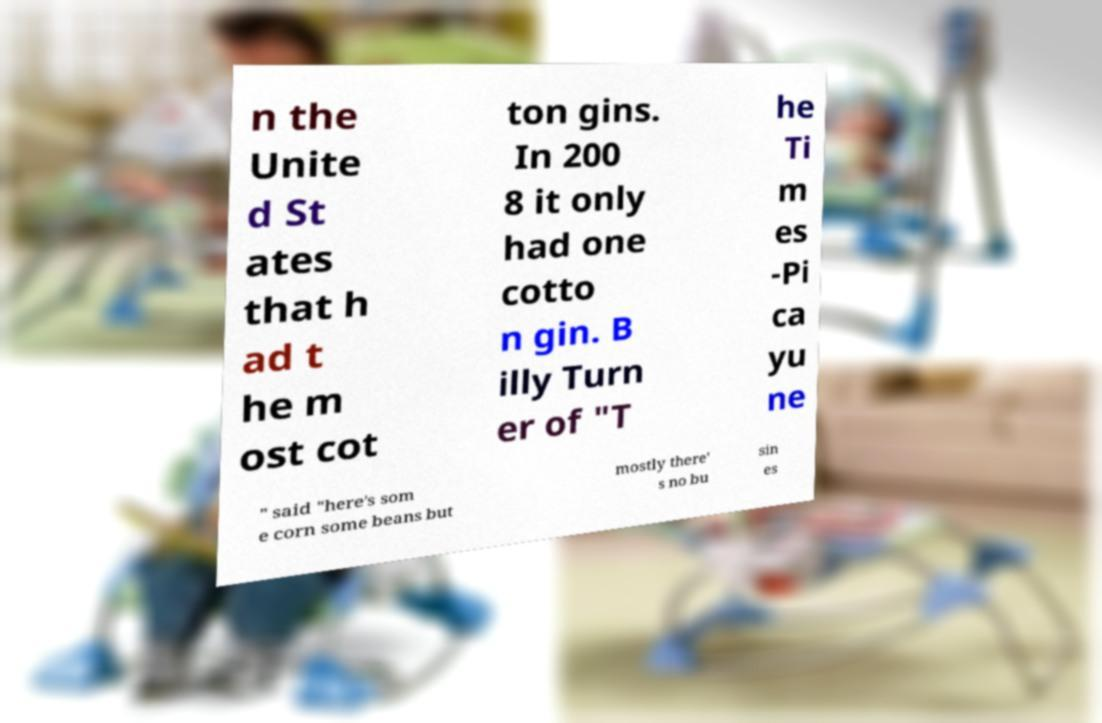Can you accurately transcribe the text from the provided image for me? n the Unite d St ates that h ad t he m ost cot ton gins. In 200 8 it only had one cotto n gin. B illy Turn er of "T he Ti m es -Pi ca yu ne " said "here's som e corn some beans but mostly there' s no bu sin es 